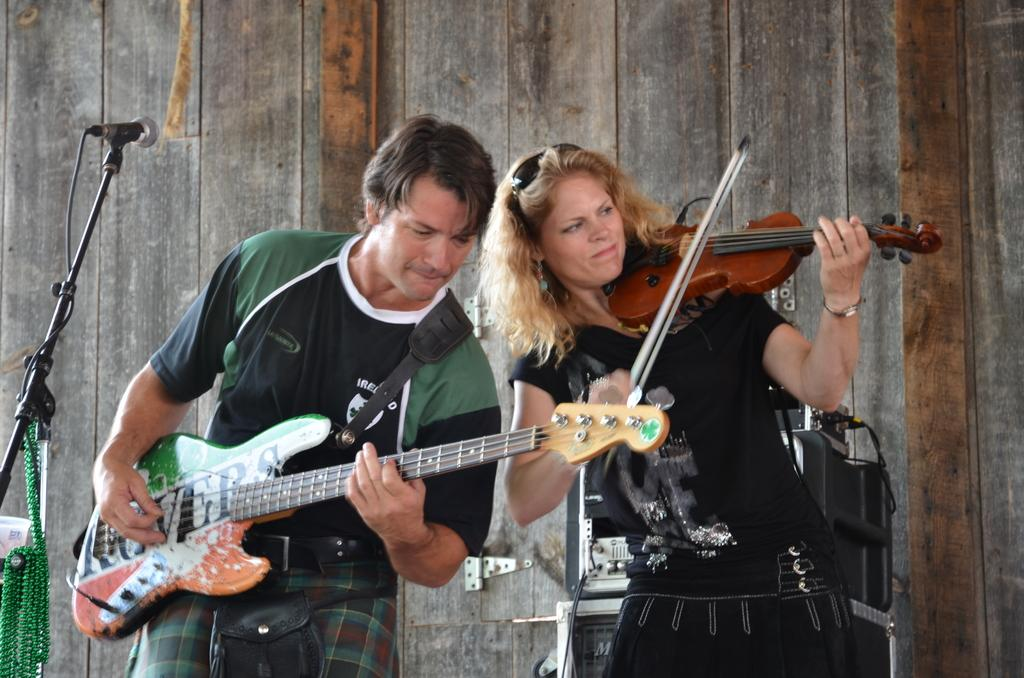What is the man in the image doing? The man is playing a guitar. What is the woman in the image doing? The woman is playing a violin. Can you describe the musical instruments being played in the image? The man is playing a guitar, and the woman is playing a violin. How many babies are visible in the image? There are no babies present in the image. What type of nail is the woman using to play the violin? The woman is not using a nail to play the violin; she is using a bow. 